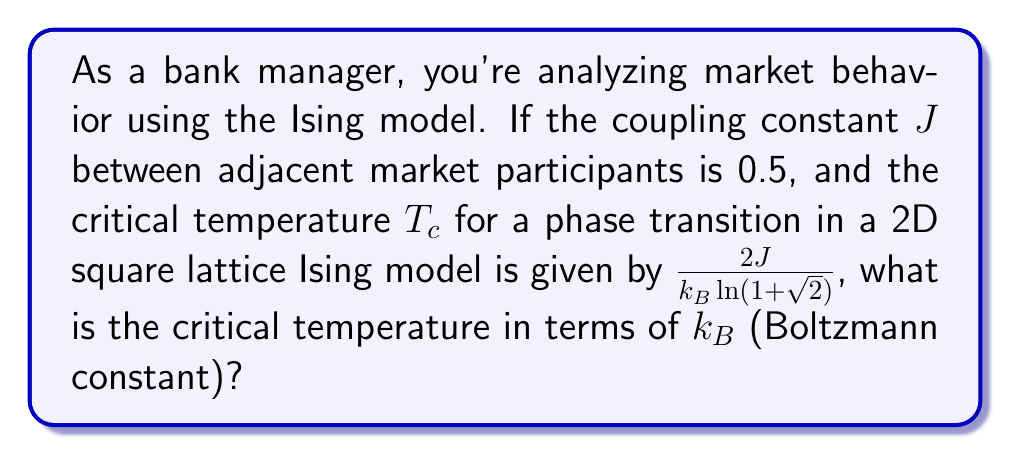Teach me how to tackle this problem. 1. We start with the given formula for the critical temperature in a 2D square lattice Ising model:

   $$T_c = \frac{2J}{k_B \ln(1+\sqrt{2})}$$

2. We're given that the coupling constant $J = 0.5$. Let's substitute this into the equation:

   $$T_c = \frac{2(0.5)}{k_B \ln(1+\sqrt{2})}$$

3. Simplify the numerator:

   $$T_c = \frac{1}{k_B \ln(1+\sqrt{2})}$$

4. The term $\ln(1+\sqrt{2})$ is a constant. We can calculate its value:

   $$\ln(1+\sqrt{2}) \approx 0.8813735870195430$$

5. Substitute this value:

   $$T_c = \frac{1}{k_B (0.8813735870195430)}$$

6. Simplify:

   $$T_c \approx \frac{1.134593603}{k_B}$$

This is our final expression for the critical temperature in terms of the Boltzmann constant $k_B$.
Answer: $T_c \approx 1.134593603k_B^{-1}$ 